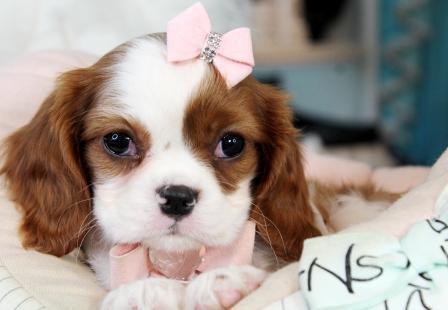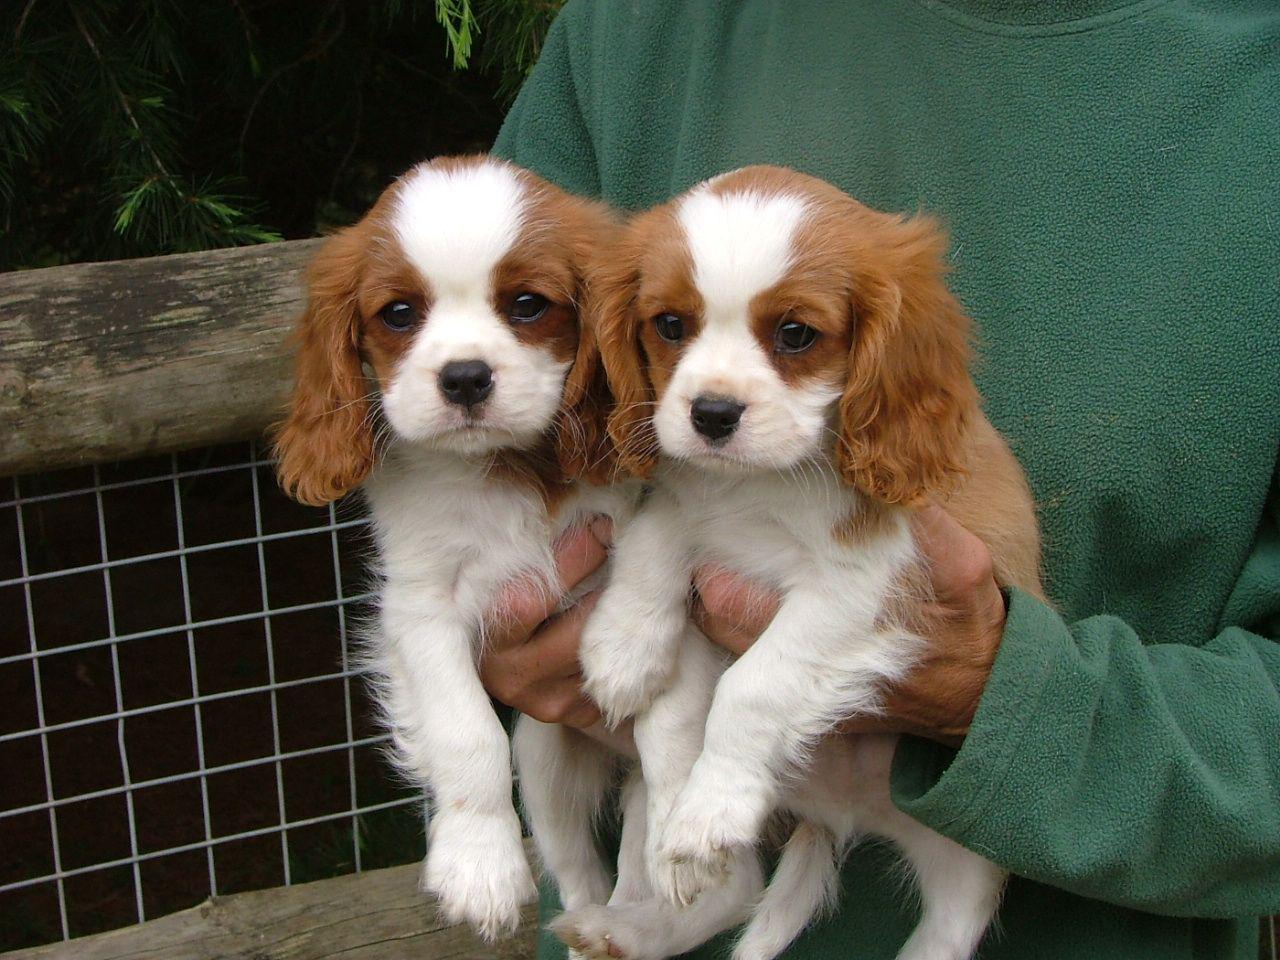The first image is the image on the left, the second image is the image on the right. Assess this claim about the two images: "An image shows exactly two look-alike puppies.". Correct or not? Answer yes or no. Yes. 